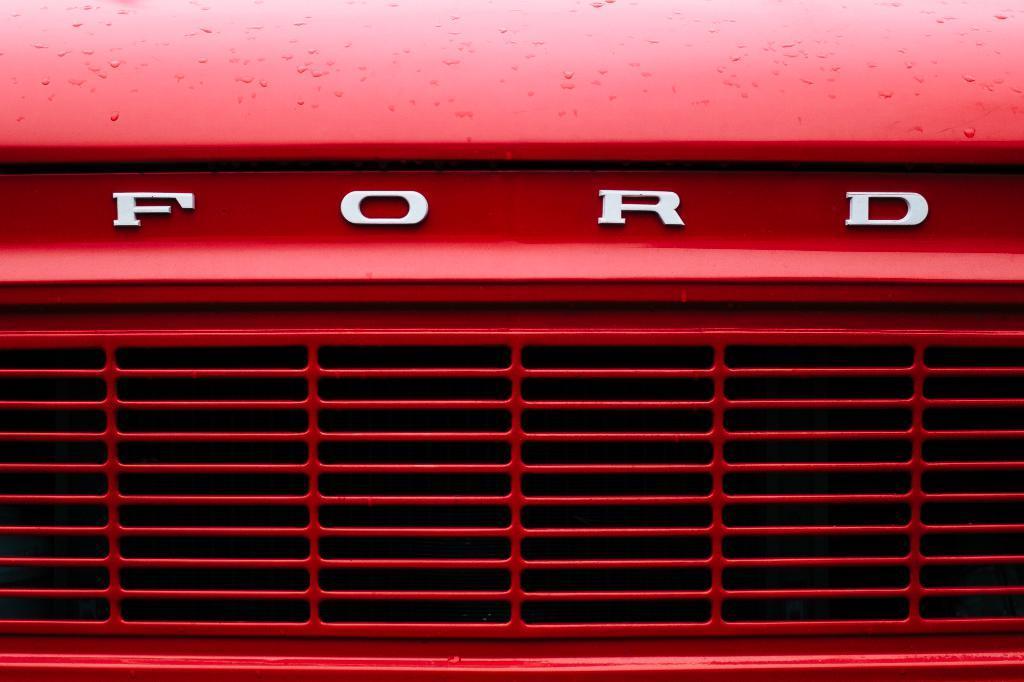Could you give a brief overview of what you see in this image? In this image we can see a front part of a car which is in red color. 